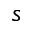<formula> <loc_0><loc_0><loc_500><loc_500>s</formula> 